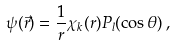<formula> <loc_0><loc_0><loc_500><loc_500>\psi ( \vec { r } ) = { \frac { 1 } { r } } \chi _ { k } ( r ) P _ { l } ( \cos \theta ) \, ,</formula> 